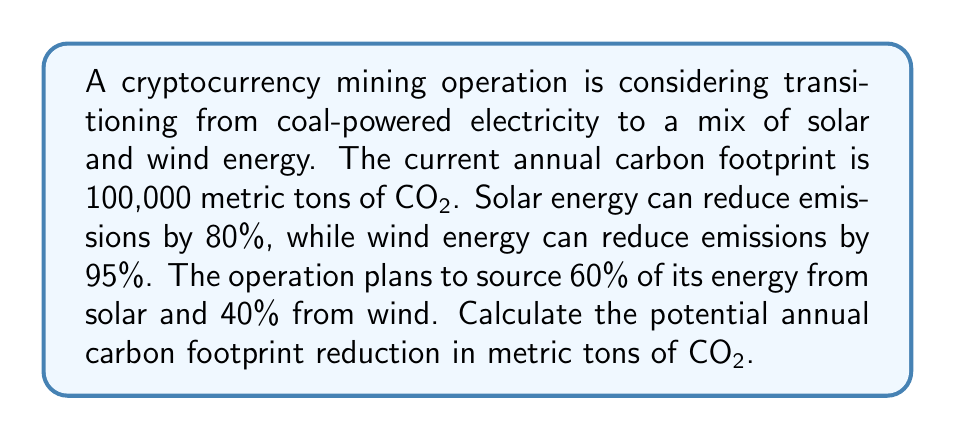Help me with this question. To solve this problem, we'll follow these steps:

1. Calculate the emission reduction factor for solar energy:
   $1 - 0.80 = 0.20$ (20% of original emissions)

2. Calculate the emission reduction factor for wind energy:
   $1 - 0.95 = 0.05$ (5% of original emissions)

3. Calculate the weighted average emission factor:
   $$(0.60 \times 0.20) + (0.40 \times 0.05) = 0.12 + 0.02 = 0.14$$

4. Calculate the new carbon footprint:
   $$100,000 \times 0.14 = 14,000$$ metric tons of CO2

5. Calculate the carbon footprint reduction:
   $$100,000 - 14,000 = 86,000$$ metric tons of CO2

Therefore, the potential annual carbon footprint reduction is 86,000 metric tons of CO2.
Answer: 86,000 metric tons of CO2 